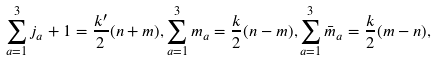Convert formula to latex. <formula><loc_0><loc_0><loc_500><loc_500>\sum _ { a = 1 } ^ { 3 } j _ { a } + 1 = \frac { k ^ { \prime } } { 2 } ( n + m ) , \sum _ { a = 1 } ^ { 3 } m _ { a } = \frac { k } { 2 } ( n - m ) , \sum _ { a = 1 } ^ { 3 } \bar { m } _ { a } = \frac { k } { 2 } ( m - n ) ,</formula> 